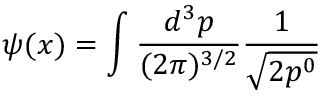Convert formula to latex. <formula><loc_0><loc_0><loc_500><loc_500>\psi ( x ) = \int \frac { d ^ { 3 } p } { ( 2 \pi ) ^ { 3 / 2 } } \frac { 1 } { \sqrt { 2 p ^ { 0 } } }</formula> 